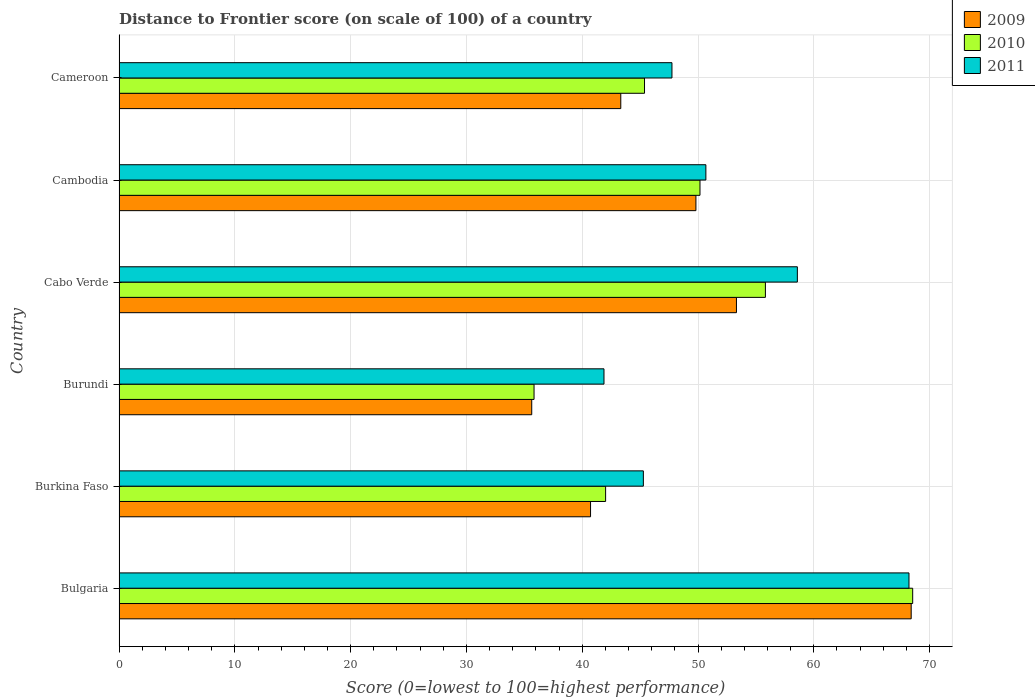Are the number of bars per tick equal to the number of legend labels?
Your answer should be compact. Yes. Are the number of bars on each tick of the Y-axis equal?
Your answer should be compact. Yes. How many bars are there on the 6th tick from the top?
Your answer should be very brief. 3. What is the label of the 1st group of bars from the top?
Give a very brief answer. Cameroon. What is the distance to frontier score of in 2010 in Bulgaria?
Ensure brevity in your answer.  68.54. Across all countries, what is the maximum distance to frontier score of in 2010?
Your answer should be compact. 68.54. Across all countries, what is the minimum distance to frontier score of in 2009?
Give a very brief answer. 35.64. In which country was the distance to frontier score of in 2009 maximum?
Keep it short and to the point. Bulgaria. In which country was the distance to frontier score of in 2009 minimum?
Ensure brevity in your answer.  Burundi. What is the total distance to frontier score of in 2010 in the graph?
Offer a terse response. 297.77. What is the difference between the distance to frontier score of in 2009 in Burundi and that in Cameroon?
Offer a terse response. -7.69. What is the difference between the distance to frontier score of in 2010 in Burundi and the distance to frontier score of in 2011 in Cabo Verde?
Give a very brief answer. -22.74. What is the average distance to frontier score of in 2011 per country?
Provide a succinct answer. 52.06. What is the difference between the distance to frontier score of in 2009 and distance to frontier score of in 2010 in Burundi?
Ensure brevity in your answer.  -0.2. What is the ratio of the distance to frontier score of in 2011 in Burundi to that in Cabo Verde?
Keep it short and to the point. 0.71. Is the distance to frontier score of in 2011 in Cabo Verde less than that in Cambodia?
Make the answer very short. No. What is the difference between the highest and the second highest distance to frontier score of in 2011?
Ensure brevity in your answer.  9.64. What is the difference between the highest and the lowest distance to frontier score of in 2010?
Make the answer very short. 32.7. What does the 2nd bar from the bottom in Cambodia represents?
Offer a very short reply. 2010. Is it the case that in every country, the sum of the distance to frontier score of in 2010 and distance to frontier score of in 2011 is greater than the distance to frontier score of in 2009?
Your answer should be very brief. Yes. Are all the bars in the graph horizontal?
Ensure brevity in your answer.  Yes. What is the difference between two consecutive major ticks on the X-axis?
Make the answer very short. 10. How many legend labels are there?
Provide a short and direct response. 3. How are the legend labels stacked?
Give a very brief answer. Vertical. What is the title of the graph?
Offer a very short reply. Distance to Frontier score (on scale of 100) of a country. Does "1996" appear as one of the legend labels in the graph?
Make the answer very short. No. What is the label or title of the X-axis?
Offer a very short reply. Score (0=lowest to 100=highest performance). What is the Score (0=lowest to 100=highest performance) in 2009 in Bulgaria?
Offer a terse response. 68.41. What is the Score (0=lowest to 100=highest performance) of 2010 in Bulgaria?
Your answer should be very brief. 68.54. What is the Score (0=lowest to 100=highest performance) of 2011 in Bulgaria?
Offer a terse response. 68.22. What is the Score (0=lowest to 100=highest performance) in 2009 in Burkina Faso?
Ensure brevity in your answer.  40.72. What is the Score (0=lowest to 100=highest performance) in 2010 in Burkina Faso?
Make the answer very short. 42.02. What is the Score (0=lowest to 100=highest performance) in 2011 in Burkina Faso?
Offer a terse response. 45.28. What is the Score (0=lowest to 100=highest performance) of 2009 in Burundi?
Give a very brief answer. 35.64. What is the Score (0=lowest to 100=highest performance) in 2010 in Burundi?
Offer a terse response. 35.84. What is the Score (0=lowest to 100=highest performance) in 2011 in Burundi?
Ensure brevity in your answer.  41.88. What is the Score (0=lowest to 100=highest performance) in 2009 in Cabo Verde?
Your answer should be compact. 53.32. What is the Score (0=lowest to 100=highest performance) in 2010 in Cabo Verde?
Your answer should be compact. 55.82. What is the Score (0=lowest to 100=highest performance) of 2011 in Cabo Verde?
Offer a very short reply. 58.58. What is the Score (0=lowest to 100=highest performance) in 2009 in Cambodia?
Provide a short and direct response. 49.82. What is the Score (0=lowest to 100=highest performance) in 2010 in Cambodia?
Ensure brevity in your answer.  50.17. What is the Score (0=lowest to 100=highest performance) of 2011 in Cambodia?
Ensure brevity in your answer.  50.68. What is the Score (0=lowest to 100=highest performance) of 2009 in Cameroon?
Your answer should be compact. 43.33. What is the Score (0=lowest to 100=highest performance) in 2010 in Cameroon?
Ensure brevity in your answer.  45.38. What is the Score (0=lowest to 100=highest performance) in 2011 in Cameroon?
Offer a very short reply. 47.75. Across all countries, what is the maximum Score (0=lowest to 100=highest performance) of 2009?
Give a very brief answer. 68.41. Across all countries, what is the maximum Score (0=lowest to 100=highest performance) in 2010?
Offer a terse response. 68.54. Across all countries, what is the maximum Score (0=lowest to 100=highest performance) of 2011?
Offer a terse response. 68.22. Across all countries, what is the minimum Score (0=lowest to 100=highest performance) in 2009?
Your answer should be very brief. 35.64. Across all countries, what is the minimum Score (0=lowest to 100=highest performance) of 2010?
Provide a short and direct response. 35.84. Across all countries, what is the minimum Score (0=lowest to 100=highest performance) in 2011?
Your response must be concise. 41.88. What is the total Score (0=lowest to 100=highest performance) of 2009 in the graph?
Provide a succinct answer. 291.24. What is the total Score (0=lowest to 100=highest performance) of 2010 in the graph?
Keep it short and to the point. 297.77. What is the total Score (0=lowest to 100=highest performance) of 2011 in the graph?
Your answer should be very brief. 312.39. What is the difference between the Score (0=lowest to 100=highest performance) of 2009 in Bulgaria and that in Burkina Faso?
Offer a terse response. 27.69. What is the difference between the Score (0=lowest to 100=highest performance) of 2010 in Bulgaria and that in Burkina Faso?
Keep it short and to the point. 26.52. What is the difference between the Score (0=lowest to 100=highest performance) in 2011 in Bulgaria and that in Burkina Faso?
Provide a succinct answer. 22.94. What is the difference between the Score (0=lowest to 100=highest performance) of 2009 in Bulgaria and that in Burundi?
Provide a succinct answer. 32.77. What is the difference between the Score (0=lowest to 100=highest performance) in 2010 in Bulgaria and that in Burundi?
Make the answer very short. 32.7. What is the difference between the Score (0=lowest to 100=highest performance) in 2011 in Bulgaria and that in Burundi?
Your answer should be very brief. 26.34. What is the difference between the Score (0=lowest to 100=highest performance) of 2009 in Bulgaria and that in Cabo Verde?
Give a very brief answer. 15.09. What is the difference between the Score (0=lowest to 100=highest performance) of 2010 in Bulgaria and that in Cabo Verde?
Your answer should be compact. 12.72. What is the difference between the Score (0=lowest to 100=highest performance) of 2011 in Bulgaria and that in Cabo Verde?
Your response must be concise. 9.64. What is the difference between the Score (0=lowest to 100=highest performance) of 2009 in Bulgaria and that in Cambodia?
Your answer should be compact. 18.59. What is the difference between the Score (0=lowest to 100=highest performance) in 2010 in Bulgaria and that in Cambodia?
Provide a succinct answer. 18.37. What is the difference between the Score (0=lowest to 100=highest performance) in 2011 in Bulgaria and that in Cambodia?
Offer a very short reply. 17.54. What is the difference between the Score (0=lowest to 100=highest performance) of 2009 in Bulgaria and that in Cameroon?
Make the answer very short. 25.08. What is the difference between the Score (0=lowest to 100=highest performance) of 2010 in Bulgaria and that in Cameroon?
Provide a succinct answer. 23.16. What is the difference between the Score (0=lowest to 100=highest performance) in 2011 in Bulgaria and that in Cameroon?
Ensure brevity in your answer.  20.47. What is the difference between the Score (0=lowest to 100=highest performance) of 2009 in Burkina Faso and that in Burundi?
Your answer should be very brief. 5.08. What is the difference between the Score (0=lowest to 100=highest performance) of 2010 in Burkina Faso and that in Burundi?
Keep it short and to the point. 6.18. What is the difference between the Score (0=lowest to 100=highest performance) of 2011 in Burkina Faso and that in Cabo Verde?
Your answer should be compact. -13.3. What is the difference between the Score (0=lowest to 100=highest performance) of 2010 in Burkina Faso and that in Cambodia?
Your response must be concise. -8.15. What is the difference between the Score (0=lowest to 100=highest performance) in 2011 in Burkina Faso and that in Cambodia?
Ensure brevity in your answer.  -5.4. What is the difference between the Score (0=lowest to 100=highest performance) in 2009 in Burkina Faso and that in Cameroon?
Give a very brief answer. -2.61. What is the difference between the Score (0=lowest to 100=highest performance) of 2010 in Burkina Faso and that in Cameroon?
Your response must be concise. -3.36. What is the difference between the Score (0=lowest to 100=highest performance) in 2011 in Burkina Faso and that in Cameroon?
Your answer should be compact. -2.47. What is the difference between the Score (0=lowest to 100=highest performance) of 2009 in Burundi and that in Cabo Verde?
Provide a short and direct response. -17.68. What is the difference between the Score (0=lowest to 100=highest performance) in 2010 in Burundi and that in Cabo Verde?
Make the answer very short. -19.98. What is the difference between the Score (0=lowest to 100=highest performance) of 2011 in Burundi and that in Cabo Verde?
Provide a short and direct response. -16.7. What is the difference between the Score (0=lowest to 100=highest performance) of 2009 in Burundi and that in Cambodia?
Offer a terse response. -14.18. What is the difference between the Score (0=lowest to 100=highest performance) of 2010 in Burundi and that in Cambodia?
Offer a terse response. -14.33. What is the difference between the Score (0=lowest to 100=highest performance) of 2011 in Burundi and that in Cambodia?
Your answer should be compact. -8.8. What is the difference between the Score (0=lowest to 100=highest performance) of 2009 in Burundi and that in Cameroon?
Ensure brevity in your answer.  -7.69. What is the difference between the Score (0=lowest to 100=highest performance) in 2010 in Burundi and that in Cameroon?
Provide a succinct answer. -9.54. What is the difference between the Score (0=lowest to 100=highest performance) in 2011 in Burundi and that in Cameroon?
Your answer should be compact. -5.87. What is the difference between the Score (0=lowest to 100=highest performance) of 2010 in Cabo Verde and that in Cambodia?
Offer a terse response. 5.65. What is the difference between the Score (0=lowest to 100=highest performance) in 2009 in Cabo Verde and that in Cameroon?
Your answer should be very brief. 9.99. What is the difference between the Score (0=lowest to 100=highest performance) of 2010 in Cabo Verde and that in Cameroon?
Provide a succinct answer. 10.44. What is the difference between the Score (0=lowest to 100=highest performance) in 2011 in Cabo Verde and that in Cameroon?
Give a very brief answer. 10.83. What is the difference between the Score (0=lowest to 100=highest performance) of 2009 in Cambodia and that in Cameroon?
Give a very brief answer. 6.49. What is the difference between the Score (0=lowest to 100=highest performance) in 2010 in Cambodia and that in Cameroon?
Give a very brief answer. 4.79. What is the difference between the Score (0=lowest to 100=highest performance) in 2011 in Cambodia and that in Cameroon?
Keep it short and to the point. 2.93. What is the difference between the Score (0=lowest to 100=highest performance) of 2009 in Bulgaria and the Score (0=lowest to 100=highest performance) of 2010 in Burkina Faso?
Give a very brief answer. 26.39. What is the difference between the Score (0=lowest to 100=highest performance) of 2009 in Bulgaria and the Score (0=lowest to 100=highest performance) of 2011 in Burkina Faso?
Your answer should be compact. 23.13. What is the difference between the Score (0=lowest to 100=highest performance) in 2010 in Bulgaria and the Score (0=lowest to 100=highest performance) in 2011 in Burkina Faso?
Offer a terse response. 23.26. What is the difference between the Score (0=lowest to 100=highest performance) of 2009 in Bulgaria and the Score (0=lowest to 100=highest performance) of 2010 in Burundi?
Your answer should be compact. 32.57. What is the difference between the Score (0=lowest to 100=highest performance) in 2009 in Bulgaria and the Score (0=lowest to 100=highest performance) in 2011 in Burundi?
Your answer should be compact. 26.53. What is the difference between the Score (0=lowest to 100=highest performance) in 2010 in Bulgaria and the Score (0=lowest to 100=highest performance) in 2011 in Burundi?
Offer a terse response. 26.66. What is the difference between the Score (0=lowest to 100=highest performance) of 2009 in Bulgaria and the Score (0=lowest to 100=highest performance) of 2010 in Cabo Verde?
Offer a terse response. 12.59. What is the difference between the Score (0=lowest to 100=highest performance) in 2009 in Bulgaria and the Score (0=lowest to 100=highest performance) in 2011 in Cabo Verde?
Provide a short and direct response. 9.83. What is the difference between the Score (0=lowest to 100=highest performance) of 2010 in Bulgaria and the Score (0=lowest to 100=highest performance) of 2011 in Cabo Verde?
Offer a very short reply. 9.96. What is the difference between the Score (0=lowest to 100=highest performance) in 2009 in Bulgaria and the Score (0=lowest to 100=highest performance) in 2010 in Cambodia?
Your answer should be compact. 18.24. What is the difference between the Score (0=lowest to 100=highest performance) in 2009 in Bulgaria and the Score (0=lowest to 100=highest performance) in 2011 in Cambodia?
Ensure brevity in your answer.  17.73. What is the difference between the Score (0=lowest to 100=highest performance) of 2010 in Bulgaria and the Score (0=lowest to 100=highest performance) of 2011 in Cambodia?
Offer a terse response. 17.86. What is the difference between the Score (0=lowest to 100=highest performance) of 2009 in Bulgaria and the Score (0=lowest to 100=highest performance) of 2010 in Cameroon?
Make the answer very short. 23.03. What is the difference between the Score (0=lowest to 100=highest performance) of 2009 in Bulgaria and the Score (0=lowest to 100=highest performance) of 2011 in Cameroon?
Provide a succinct answer. 20.66. What is the difference between the Score (0=lowest to 100=highest performance) in 2010 in Bulgaria and the Score (0=lowest to 100=highest performance) in 2011 in Cameroon?
Ensure brevity in your answer.  20.79. What is the difference between the Score (0=lowest to 100=highest performance) of 2009 in Burkina Faso and the Score (0=lowest to 100=highest performance) of 2010 in Burundi?
Make the answer very short. 4.88. What is the difference between the Score (0=lowest to 100=highest performance) of 2009 in Burkina Faso and the Score (0=lowest to 100=highest performance) of 2011 in Burundi?
Give a very brief answer. -1.16. What is the difference between the Score (0=lowest to 100=highest performance) in 2010 in Burkina Faso and the Score (0=lowest to 100=highest performance) in 2011 in Burundi?
Give a very brief answer. 0.14. What is the difference between the Score (0=lowest to 100=highest performance) in 2009 in Burkina Faso and the Score (0=lowest to 100=highest performance) in 2010 in Cabo Verde?
Your answer should be compact. -15.1. What is the difference between the Score (0=lowest to 100=highest performance) of 2009 in Burkina Faso and the Score (0=lowest to 100=highest performance) of 2011 in Cabo Verde?
Ensure brevity in your answer.  -17.86. What is the difference between the Score (0=lowest to 100=highest performance) in 2010 in Burkina Faso and the Score (0=lowest to 100=highest performance) in 2011 in Cabo Verde?
Your answer should be very brief. -16.56. What is the difference between the Score (0=lowest to 100=highest performance) of 2009 in Burkina Faso and the Score (0=lowest to 100=highest performance) of 2010 in Cambodia?
Keep it short and to the point. -9.45. What is the difference between the Score (0=lowest to 100=highest performance) in 2009 in Burkina Faso and the Score (0=lowest to 100=highest performance) in 2011 in Cambodia?
Keep it short and to the point. -9.96. What is the difference between the Score (0=lowest to 100=highest performance) of 2010 in Burkina Faso and the Score (0=lowest to 100=highest performance) of 2011 in Cambodia?
Your answer should be very brief. -8.66. What is the difference between the Score (0=lowest to 100=highest performance) in 2009 in Burkina Faso and the Score (0=lowest to 100=highest performance) in 2010 in Cameroon?
Provide a short and direct response. -4.66. What is the difference between the Score (0=lowest to 100=highest performance) of 2009 in Burkina Faso and the Score (0=lowest to 100=highest performance) of 2011 in Cameroon?
Make the answer very short. -7.03. What is the difference between the Score (0=lowest to 100=highest performance) of 2010 in Burkina Faso and the Score (0=lowest to 100=highest performance) of 2011 in Cameroon?
Keep it short and to the point. -5.73. What is the difference between the Score (0=lowest to 100=highest performance) of 2009 in Burundi and the Score (0=lowest to 100=highest performance) of 2010 in Cabo Verde?
Make the answer very short. -20.18. What is the difference between the Score (0=lowest to 100=highest performance) in 2009 in Burundi and the Score (0=lowest to 100=highest performance) in 2011 in Cabo Verde?
Your answer should be compact. -22.94. What is the difference between the Score (0=lowest to 100=highest performance) in 2010 in Burundi and the Score (0=lowest to 100=highest performance) in 2011 in Cabo Verde?
Keep it short and to the point. -22.74. What is the difference between the Score (0=lowest to 100=highest performance) in 2009 in Burundi and the Score (0=lowest to 100=highest performance) in 2010 in Cambodia?
Offer a terse response. -14.53. What is the difference between the Score (0=lowest to 100=highest performance) in 2009 in Burundi and the Score (0=lowest to 100=highest performance) in 2011 in Cambodia?
Keep it short and to the point. -15.04. What is the difference between the Score (0=lowest to 100=highest performance) of 2010 in Burundi and the Score (0=lowest to 100=highest performance) of 2011 in Cambodia?
Make the answer very short. -14.84. What is the difference between the Score (0=lowest to 100=highest performance) in 2009 in Burundi and the Score (0=lowest to 100=highest performance) in 2010 in Cameroon?
Your response must be concise. -9.74. What is the difference between the Score (0=lowest to 100=highest performance) in 2009 in Burundi and the Score (0=lowest to 100=highest performance) in 2011 in Cameroon?
Offer a very short reply. -12.11. What is the difference between the Score (0=lowest to 100=highest performance) in 2010 in Burundi and the Score (0=lowest to 100=highest performance) in 2011 in Cameroon?
Provide a succinct answer. -11.91. What is the difference between the Score (0=lowest to 100=highest performance) in 2009 in Cabo Verde and the Score (0=lowest to 100=highest performance) in 2010 in Cambodia?
Keep it short and to the point. 3.15. What is the difference between the Score (0=lowest to 100=highest performance) in 2009 in Cabo Verde and the Score (0=lowest to 100=highest performance) in 2011 in Cambodia?
Keep it short and to the point. 2.64. What is the difference between the Score (0=lowest to 100=highest performance) in 2010 in Cabo Verde and the Score (0=lowest to 100=highest performance) in 2011 in Cambodia?
Give a very brief answer. 5.14. What is the difference between the Score (0=lowest to 100=highest performance) in 2009 in Cabo Verde and the Score (0=lowest to 100=highest performance) in 2010 in Cameroon?
Give a very brief answer. 7.94. What is the difference between the Score (0=lowest to 100=highest performance) of 2009 in Cabo Verde and the Score (0=lowest to 100=highest performance) of 2011 in Cameroon?
Your answer should be very brief. 5.57. What is the difference between the Score (0=lowest to 100=highest performance) in 2010 in Cabo Verde and the Score (0=lowest to 100=highest performance) in 2011 in Cameroon?
Provide a succinct answer. 8.07. What is the difference between the Score (0=lowest to 100=highest performance) in 2009 in Cambodia and the Score (0=lowest to 100=highest performance) in 2010 in Cameroon?
Ensure brevity in your answer.  4.44. What is the difference between the Score (0=lowest to 100=highest performance) of 2009 in Cambodia and the Score (0=lowest to 100=highest performance) of 2011 in Cameroon?
Your response must be concise. 2.07. What is the difference between the Score (0=lowest to 100=highest performance) in 2010 in Cambodia and the Score (0=lowest to 100=highest performance) in 2011 in Cameroon?
Ensure brevity in your answer.  2.42. What is the average Score (0=lowest to 100=highest performance) of 2009 per country?
Ensure brevity in your answer.  48.54. What is the average Score (0=lowest to 100=highest performance) of 2010 per country?
Make the answer very short. 49.63. What is the average Score (0=lowest to 100=highest performance) in 2011 per country?
Ensure brevity in your answer.  52.06. What is the difference between the Score (0=lowest to 100=highest performance) of 2009 and Score (0=lowest to 100=highest performance) of 2010 in Bulgaria?
Offer a terse response. -0.13. What is the difference between the Score (0=lowest to 100=highest performance) of 2009 and Score (0=lowest to 100=highest performance) of 2011 in Bulgaria?
Your answer should be very brief. 0.19. What is the difference between the Score (0=lowest to 100=highest performance) in 2010 and Score (0=lowest to 100=highest performance) in 2011 in Bulgaria?
Make the answer very short. 0.32. What is the difference between the Score (0=lowest to 100=highest performance) in 2009 and Score (0=lowest to 100=highest performance) in 2011 in Burkina Faso?
Offer a very short reply. -4.56. What is the difference between the Score (0=lowest to 100=highest performance) of 2010 and Score (0=lowest to 100=highest performance) of 2011 in Burkina Faso?
Ensure brevity in your answer.  -3.26. What is the difference between the Score (0=lowest to 100=highest performance) of 2009 and Score (0=lowest to 100=highest performance) of 2010 in Burundi?
Provide a succinct answer. -0.2. What is the difference between the Score (0=lowest to 100=highest performance) in 2009 and Score (0=lowest to 100=highest performance) in 2011 in Burundi?
Provide a succinct answer. -6.24. What is the difference between the Score (0=lowest to 100=highest performance) of 2010 and Score (0=lowest to 100=highest performance) of 2011 in Burundi?
Offer a very short reply. -6.04. What is the difference between the Score (0=lowest to 100=highest performance) of 2009 and Score (0=lowest to 100=highest performance) of 2011 in Cabo Verde?
Provide a short and direct response. -5.26. What is the difference between the Score (0=lowest to 100=highest performance) in 2010 and Score (0=lowest to 100=highest performance) in 2011 in Cabo Verde?
Keep it short and to the point. -2.76. What is the difference between the Score (0=lowest to 100=highest performance) of 2009 and Score (0=lowest to 100=highest performance) of 2010 in Cambodia?
Your response must be concise. -0.35. What is the difference between the Score (0=lowest to 100=highest performance) in 2009 and Score (0=lowest to 100=highest performance) in 2011 in Cambodia?
Offer a terse response. -0.86. What is the difference between the Score (0=lowest to 100=highest performance) in 2010 and Score (0=lowest to 100=highest performance) in 2011 in Cambodia?
Your answer should be very brief. -0.51. What is the difference between the Score (0=lowest to 100=highest performance) in 2009 and Score (0=lowest to 100=highest performance) in 2010 in Cameroon?
Give a very brief answer. -2.05. What is the difference between the Score (0=lowest to 100=highest performance) of 2009 and Score (0=lowest to 100=highest performance) of 2011 in Cameroon?
Give a very brief answer. -4.42. What is the difference between the Score (0=lowest to 100=highest performance) in 2010 and Score (0=lowest to 100=highest performance) in 2011 in Cameroon?
Your answer should be very brief. -2.37. What is the ratio of the Score (0=lowest to 100=highest performance) of 2009 in Bulgaria to that in Burkina Faso?
Give a very brief answer. 1.68. What is the ratio of the Score (0=lowest to 100=highest performance) in 2010 in Bulgaria to that in Burkina Faso?
Provide a succinct answer. 1.63. What is the ratio of the Score (0=lowest to 100=highest performance) of 2011 in Bulgaria to that in Burkina Faso?
Ensure brevity in your answer.  1.51. What is the ratio of the Score (0=lowest to 100=highest performance) in 2009 in Bulgaria to that in Burundi?
Your answer should be very brief. 1.92. What is the ratio of the Score (0=lowest to 100=highest performance) in 2010 in Bulgaria to that in Burundi?
Ensure brevity in your answer.  1.91. What is the ratio of the Score (0=lowest to 100=highest performance) of 2011 in Bulgaria to that in Burundi?
Your response must be concise. 1.63. What is the ratio of the Score (0=lowest to 100=highest performance) in 2009 in Bulgaria to that in Cabo Verde?
Ensure brevity in your answer.  1.28. What is the ratio of the Score (0=lowest to 100=highest performance) of 2010 in Bulgaria to that in Cabo Verde?
Give a very brief answer. 1.23. What is the ratio of the Score (0=lowest to 100=highest performance) of 2011 in Bulgaria to that in Cabo Verde?
Give a very brief answer. 1.16. What is the ratio of the Score (0=lowest to 100=highest performance) of 2009 in Bulgaria to that in Cambodia?
Make the answer very short. 1.37. What is the ratio of the Score (0=lowest to 100=highest performance) in 2010 in Bulgaria to that in Cambodia?
Provide a succinct answer. 1.37. What is the ratio of the Score (0=lowest to 100=highest performance) of 2011 in Bulgaria to that in Cambodia?
Offer a very short reply. 1.35. What is the ratio of the Score (0=lowest to 100=highest performance) in 2009 in Bulgaria to that in Cameroon?
Your answer should be very brief. 1.58. What is the ratio of the Score (0=lowest to 100=highest performance) of 2010 in Bulgaria to that in Cameroon?
Offer a terse response. 1.51. What is the ratio of the Score (0=lowest to 100=highest performance) in 2011 in Bulgaria to that in Cameroon?
Give a very brief answer. 1.43. What is the ratio of the Score (0=lowest to 100=highest performance) of 2009 in Burkina Faso to that in Burundi?
Make the answer very short. 1.14. What is the ratio of the Score (0=lowest to 100=highest performance) in 2010 in Burkina Faso to that in Burundi?
Your answer should be very brief. 1.17. What is the ratio of the Score (0=lowest to 100=highest performance) of 2011 in Burkina Faso to that in Burundi?
Ensure brevity in your answer.  1.08. What is the ratio of the Score (0=lowest to 100=highest performance) of 2009 in Burkina Faso to that in Cabo Verde?
Make the answer very short. 0.76. What is the ratio of the Score (0=lowest to 100=highest performance) of 2010 in Burkina Faso to that in Cabo Verde?
Offer a terse response. 0.75. What is the ratio of the Score (0=lowest to 100=highest performance) of 2011 in Burkina Faso to that in Cabo Verde?
Your answer should be compact. 0.77. What is the ratio of the Score (0=lowest to 100=highest performance) in 2009 in Burkina Faso to that in Cambodia?
Your answer should be compact. 0.82. What is the ratio of the Score (0=lowest to 100=highest performance) in 2010 in Burkina Faso to that in Cambodia?
Keep it short and to the point. 0.84. What is the ratio of the Score (0=lowest to 100=highest performance) in 2011 in Burkina Faso to that in Cambodia?
Offer a very short reply. 0.89. What is the ratio of the Score (0=lowest to 100=highest performance) in 2009 in Burkina Faso to that in Cameroon?
Give a very brief answer. 0.94. What is the ratio of the Score (0=lowest to 100=highest performance) in 2010 in Burkina Faso to that in Cameroon?
Make the answer very short. 0.93. What is the ratio of the Score (0=lowest to 100=highest performance) in 2011 in Burkina Faso to that in Cameroon?
Offer a terse response. 0.95. What is the ratio of the Score (0=lowest to 100=highest performance) in 2009 in Burundi to that in Cabo Verde?
Offer a terse response. 0.67. What is the ratio of the Score (0=lowest to 100=highest performance) in 2010 in Burundi to that in Cabo Verde?
Your response must be concise. 0.64. What is the ratio of the Score (0=lowest to 100=highest performance) of 2011 in Burundi to that in Cabo Verde?
Give a very brief answer. 0.71. What is the ratio of the Score (0=lowest to 100=highest performance) in 2009 in Burundi to that in Cambodia?
Provide a succinct answer. 0.72. What is the ratio of the Score (0=lowest to 100=highest performance) of 2010 in Burundi to that in Cambodia?
Your response must be concise. 0.71. What is the ratio of the Score (0=lowest to 100=highest performance) of 2011 in Burundi to that in Cambodia?
Offer a terse response. 0.83. What is the ratio of the Score (0=lowest to 100=highest performance) of 2009 in Burundi to that in Cameroon?
Provide a succinct answer. 0.82. What is the ratio of the Score (0=lowest to 100=highest performance) of 2010 in Burundi to that in Cameroon?
Your answer should be very brief. 0.79. What is the ratio of the Score (0=lowest to 100=highest performance) of 2011 in Burundi to that in Cameroon?
Keep it short and to the point. 0.88. What is the ratio of the Score (0=lowest to 100=highest performance) of 2009 in Cabo Verde to that in Cambodia?
Offer a very short reply. 1.07. What is the ratio of the Score (0=lowest to 100=highest performance) of 2010 in Cabo Verde to that in Cambodia?
Make the answer very short. 1.11. What is the ratio of the Score (0=lowest to 100=highest performance) in 2011 in Cabo Verde to that in Cambodia?
Ensure brevity in your answer.  1.16. What is the ratio of the Score (0=lowest to 100=highest performance) of 2009 in Cabo Verde to that in Cameroon?
Give a very brief answer. 1.23. What is the ratio of the Score (0=lowest to 100=highest performance) of 2010 in Cabo Verde to that in Cameroon?
Your answer should be very brief. 1.23. What is the ratio of the Score (0=lowest to 100=highest performance) of 2011 in Cabo Verde to that in Cameroon?
Keep it short and to the point. 1.23. What is the ratio of the Score (0=lowest to 100=highest performance) in 2009 in Cambodia to that in Cameroon?
Give a very brief answer. 1.15. What is the ratio of the Score (0=lowest to 100=highest performance) of 2010 in Cambodia to that in Cameroon?
Your answer should be compact. 1.11. What is the ratio of the Score (0=lowest to 100=highest performance) in 2011 in Cambodia to that in Cameroon?
Provide a short and direct response. 1.06. What is the difference between the highest and the second highest Score (0=lowest to 100=highest performance) in 2009?
Make the answer very short. 15.09. What is the difference between the highest and the second highest Score (0=lowest to 100=highest performance) of 2010?
Keep it short and to the point. 12.72. What is the difference between the highest and the second highest Score (0=lowest to 100=highest performance) in 2011?
Keep it short and to the point. 9.64. What is the difference between the highest and the lowest Score (0=lowest to 100=highest performance) in 2009?
Your response must be concise. 32.77. What is the difference between the highest and the lowest Score (0=lowest to 100=highest performance) of 2010?
Your response must be concise. 32.7. What is the difference between the highest and the lowest Score (0=lowest to 100=highest performance) in 2011?
Provide a short and direct response. 26.34. 